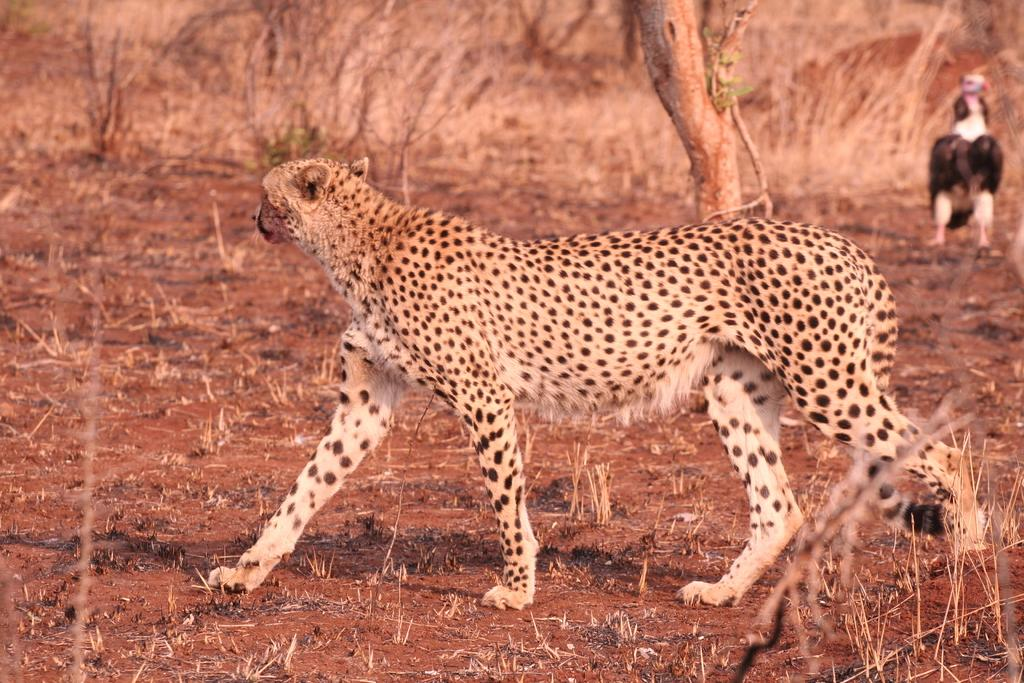What is the main subject in the center of the image? There is a leopard in the center of the image. What can be seen in the background of the image? There is another animal and trees in the background of the image. What type of terrain is visible at the bottom of the image? There is sand and grass at the bottom of the image. What type of calculator is the leopard using in the image? There is no calculator present in the image; it features a leopard and other animals in a natural setting. 